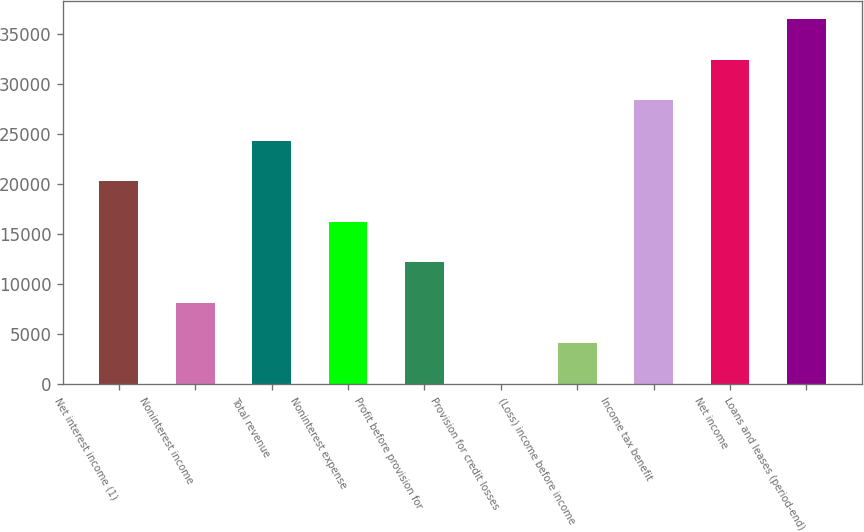Convert chart. <chart><loc_0><loc_0><loc_500><loc_500><bar_chart><fcel>Net interest income (1)<fcel>Noninterest income<fcel>Total revenue<fcel>Noninterest expense<fcel>Profit before provision for<fcel>Provision for credit losses<fcel>(Loss) income before income<fcel>Income tax benefit<fcel>Net income<fcel>Loans and leases (period-end)<nl><fcel>20264.5<fcel>8128<fcel>24310<fcel>16219<fcel>12173.5<fcel>37<fcel>4082.5<fcel>28355.5<fcel>32401<fcel>36446.5<nl></chart> 